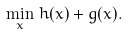Convert formula to latex. <formula><loc_0><loc_0><loc_500><loc_500>\min _ { x } \, h ( x ) + g ( x ) .</formula> 